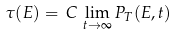<formula> <loc_0><loc_0><loc_500><loc_500>\tau ( E ) = \, C \, \lim _ { t \rightarrow \infty } P _ { T } ( E , t )</formula> 